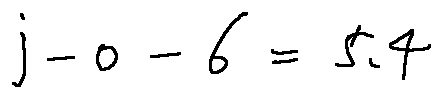<formula> <loc_0><loc_0><loc_500><loc_500>j - o - 6 = 5 . 4</formula> 